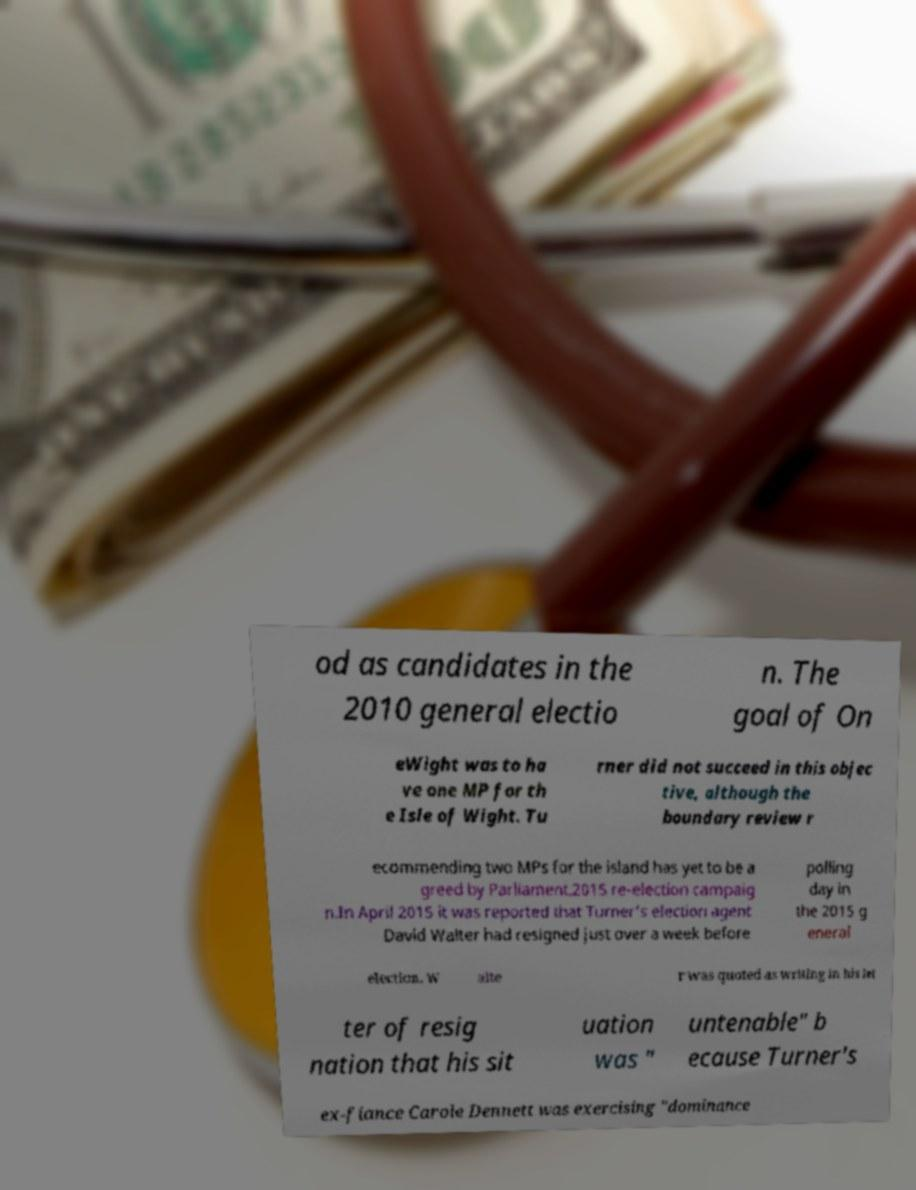Can you read and provide the text displayed in the image?This photo seems to have some interesting text. Can you extract and type it out for me? od as candidates in the 2010 general electio n. The goal of On eWight was to ha ve one MP for th e Isle of Wight. Tu rner did not succeed in this objec tive, although the boundary review r ecommending two MPs for the island has yet to be a greed by Parliament.2015 re-election campaig n.In April 2015 it was reported that Turner's election agent David Walter had resigned just over a week before polling day in the 2015 g eneral election. W alte r was quoted as writing in his let ter of resig nation that his sit uation was " untenable" b ecause Turner's ex-fiance Carole Dennett was exercising "dominance 